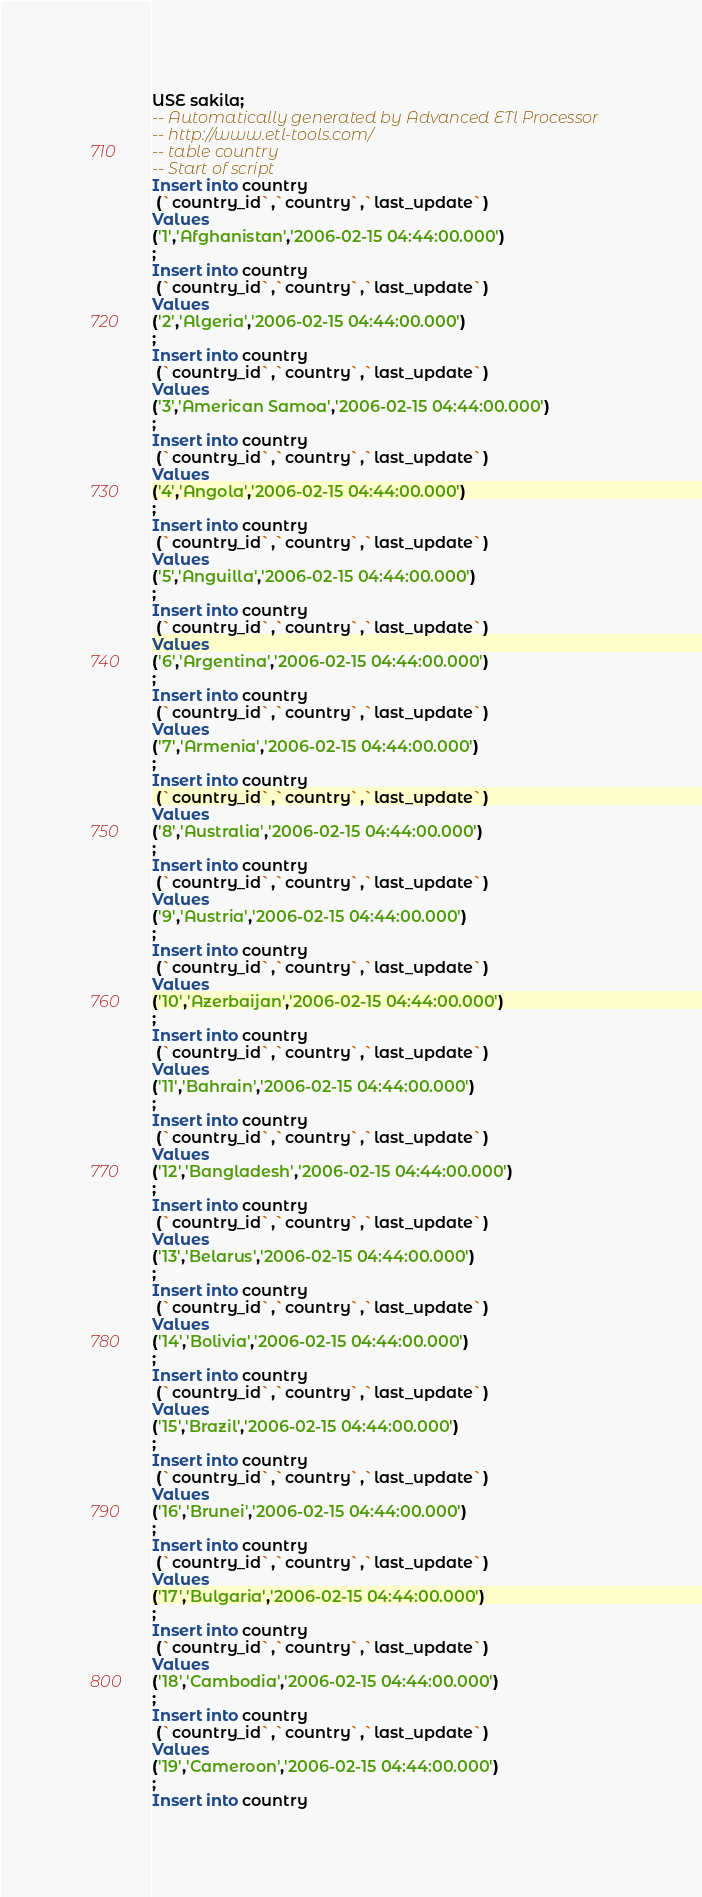<code> <loc_0><loc_0><loc_500><loc_500><_SQL_>USE sakila;
-- Automatically generated by Advanced ETl Processor
-- http://www.etl-tools.com/
-- table country
-- Start of script
Insert into country
 (`country_id`,`country`,`last_update`)
Values
('1','Afghanistan','2006-02-15 04:44:00.000')
;
Insert into country
 (`country_id`,`country`,`last_update`)
Values
('2','Algeria','2006-02-15 04:44:00.000')
;
Insert into country
 (`country_id`,`country`,`last_update`)
Values
('3','American Samoa','2006-02-15 04:44:00.000')
;
Insert into country
 (`country_id`,`country`,`last_update`)
Values
('4','Angola','2006-02-15 04:44:00.000')
;
Insert into country
 (`country_id`,`country`,`last_update`)
Values
('5','Anguilla','2006-02-15 04:44:00.000')
;
Insert into country
 (`country_id`,`country`,`last_update`)
Values
('6','Argentina','2006-02-15 04:44:00.000')
;
Insert into country
 (`country_id`,`country`,`last_update`)
Values
('7','Armenia','2006-02-15 04:44:00.000')
;
Insert into country
 (`country_id`,`country`,`last_update`)
Values
('8','Australia','2006-02-15 04:44:00.000')
;
Insert into country
 (`country_id`,`country`,`last_update`)
Values
('9','Austria','2006-02-15 04:44:00.000')
;
Insert into country
 (`country_id`,`country`,`last_update`)
Values
('10','Azerbaijan','2006-02-15 04:44:00.000')
;
Insert into country
 (`country_id`,`country`,`last_update`)
Values
('11','Bahrain','2006-02-15 04:44:00.000')
;
Insert into country
 (`country_id`,`country`,`last_update`)
Values
('12','Bangladesh','2006-02-15 04:44:00.000')
;
Insert into country
 (`country_id`,`country`,`last_update`)
Values
('13','Belarus','2006-02-15 04:44:00.000')
;
Insert into country
 (`country_id`,`country`,`last_update`)
Values
('14','Bolivia','2006-02-15 04:44:00.000')
;
Insert into country
 (`country_id`,`country`,`last_update`)
Values
('15','Brazil','2006-02-15 04:44:00.000')
;
Insert into country
 (`country_id`,`country`,`last_update`)
Values
('16','Brunei','2006-02-15 04:44:00.000')
;
Insert into country
 (`country_id`,`country`,`last_update`)
Values
('17','Bulgaria','2006-02-15 04:44:00.000')
;
Insert into country
 (`country_id`,`country`,`last_update`)
Values
('18','Cambodia','2006-02-15 04:44:00.000')
;
Insert into country
 (`country_id`,`country`,`last_update`)
Values
('19','Cameroon','2006-02-15 04:44:00.000')
;
Insert into country</code> 